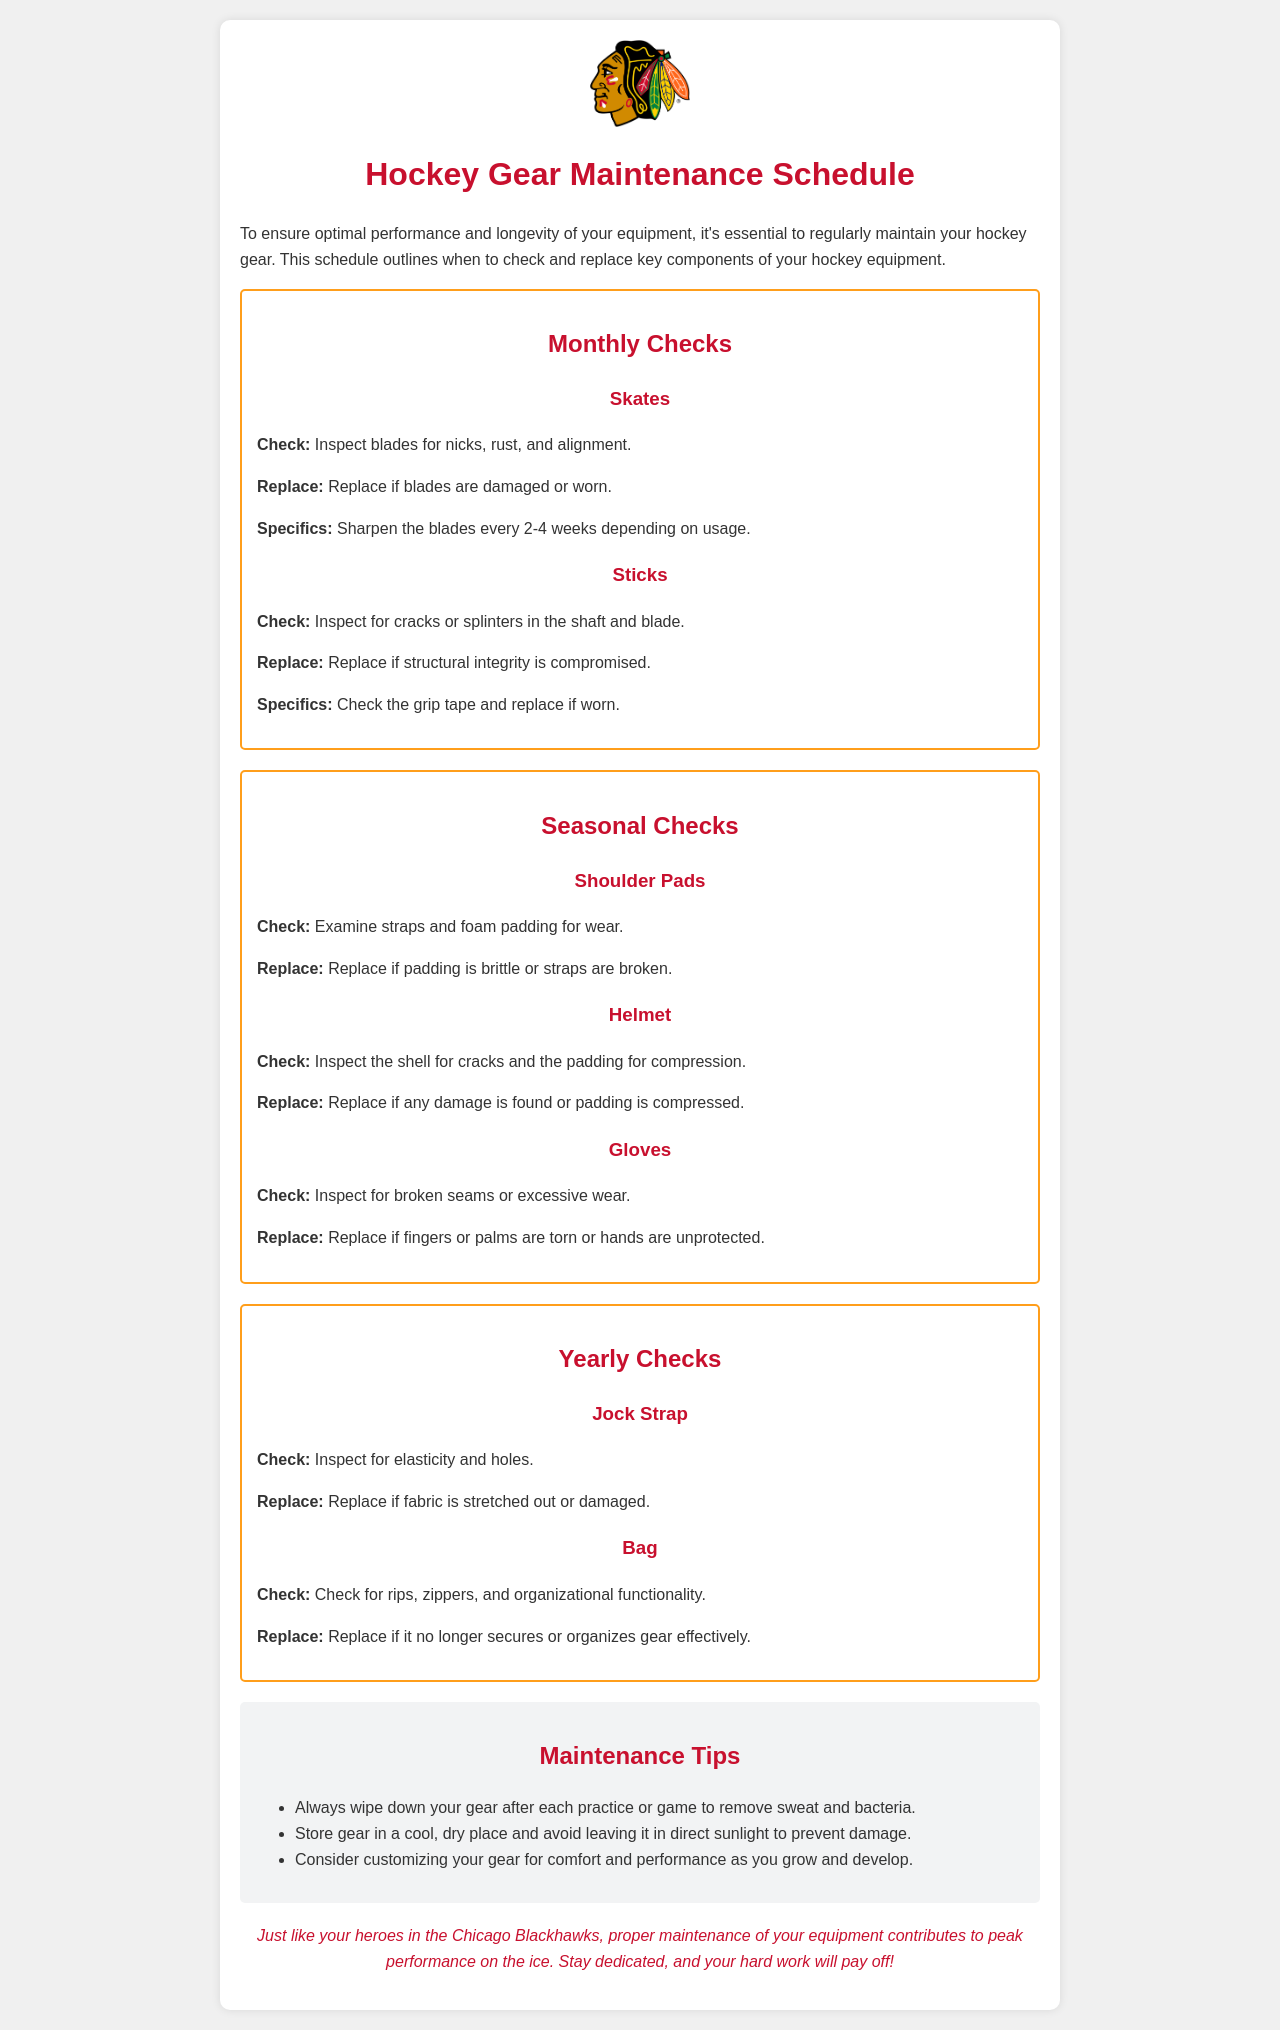What should be inspected for skates? The document states that skates should be checked for nicks, rust, and alignment.
Answer: Nicks, rust, and alignment How often should blades be sharpened? The specific section mentions that blades should be sharpened every 2-4 weeks depending on usage.
Answer: Every 2-4 weeks What is checked for shoulder pads? The document indicates that shoulder pads should be inspected for wear in straps and foam padding.
Answer: Straps and foam padding When should the helmet be replaced? The document states that the helmet should be replaced if any damage is found or padding is compressed.
Answer: If damaged or compressed What is the checking frequency for jock straps? According to the document, jock straps are checked yearly.
Answer: Yearly What should be inspected on sticks? The document mentions that sticks should be checked for cracks or splinters in the shaft and blade.
Answer: Cracks or splinters What item is recommended to be replaced if fabric is stretched out? The document specifies that jock straps should be replaced if fabric is stretched out or damaged.
Answer: Jock Strap What are the tips regarding gear storage? The document advises to store gear in a cool, dry place and avoid leaving it in direct sunlight.
Answer: Cool, dry place Which gear should be replaced if fingers or palms are torn? The document specifies that gloves should be replaced if fingers or palms are torn or hands are unprotected.
Answer: Gloves 